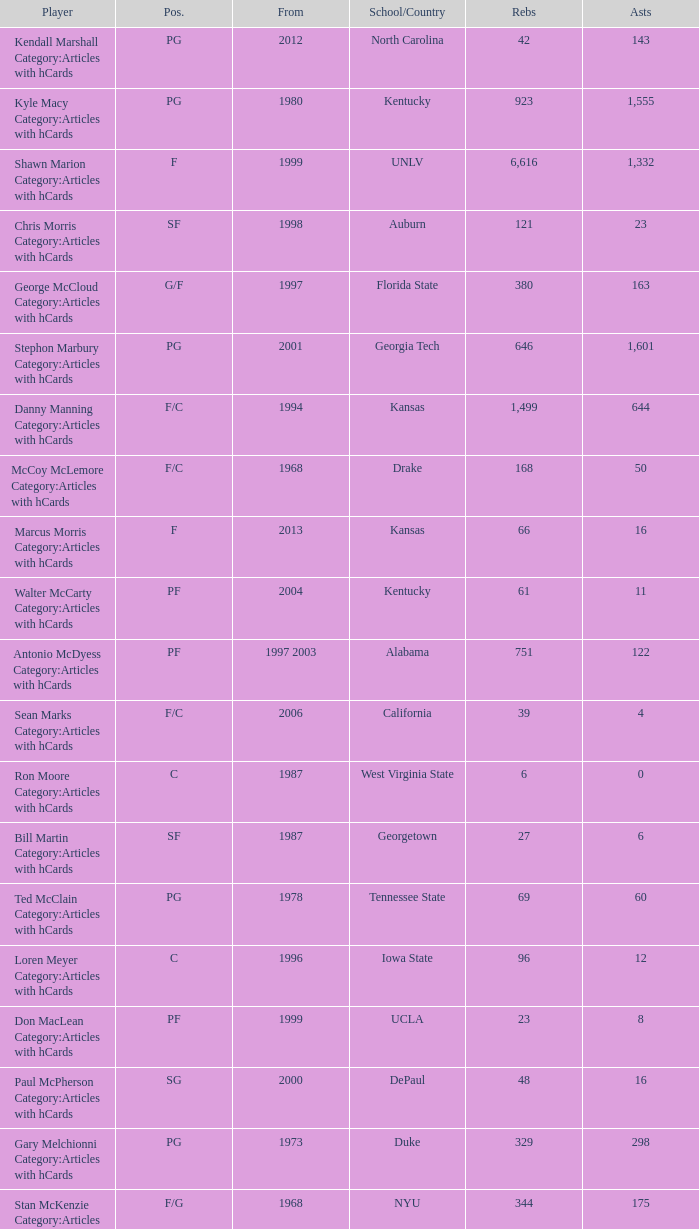What position does the player from arkansas play? C. 